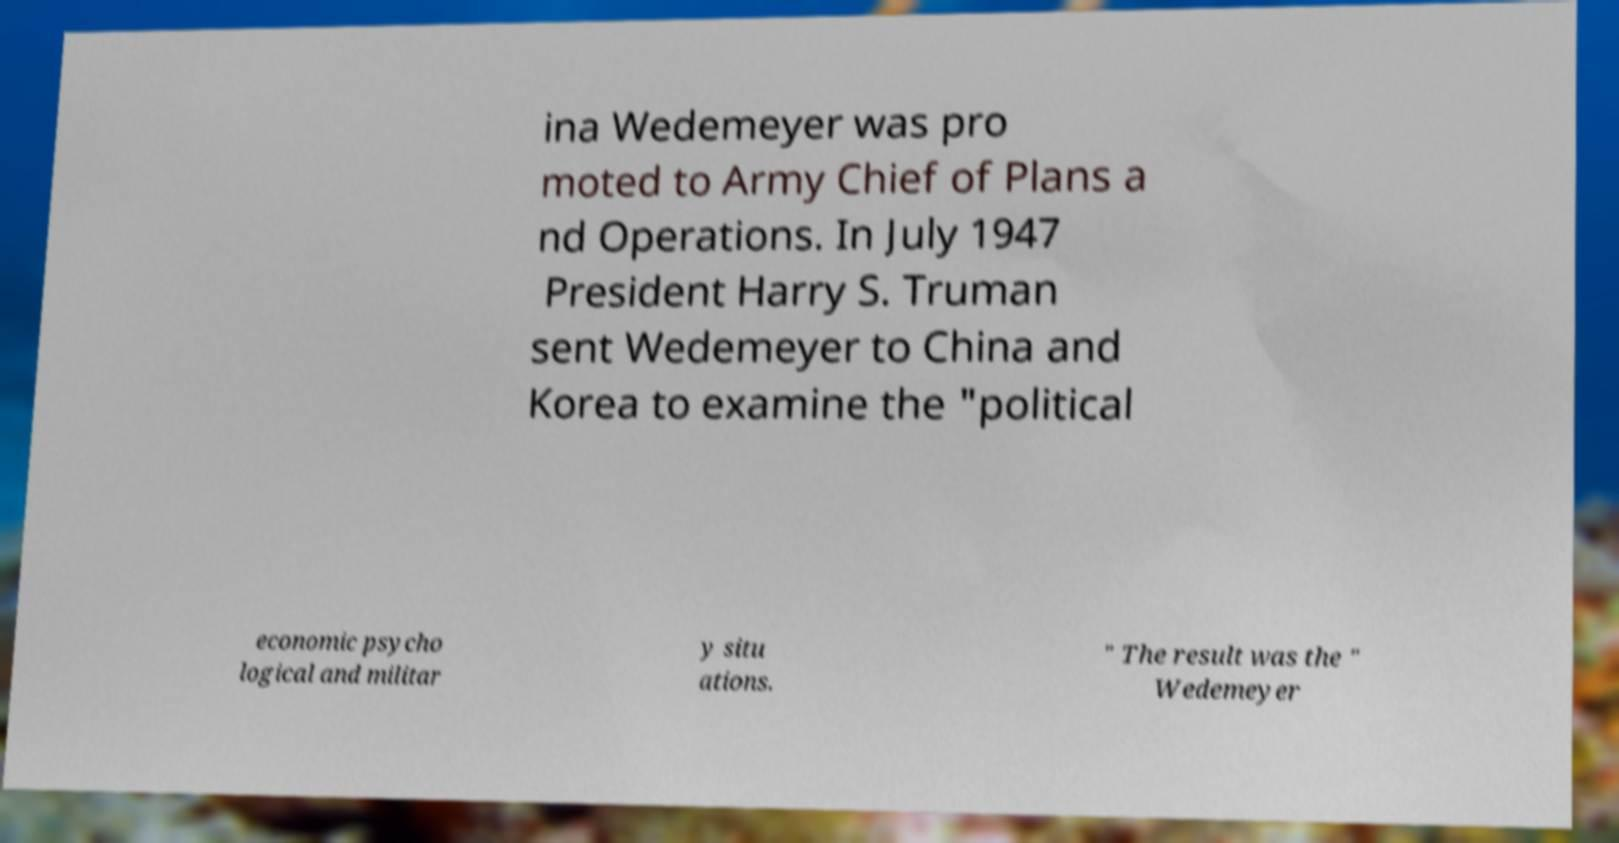For documentation purposes, I need the text within this image transcribed. Could you provide that? ina Wedemeyer was pro moted to Army Chief of Plans a nd Operations. In July 1947 President Harry S. Truman sent Wedemeyer to China and Korea to examine the "political economic psycho logical and militar y situ ations. " The result was the " Wedemeyer 